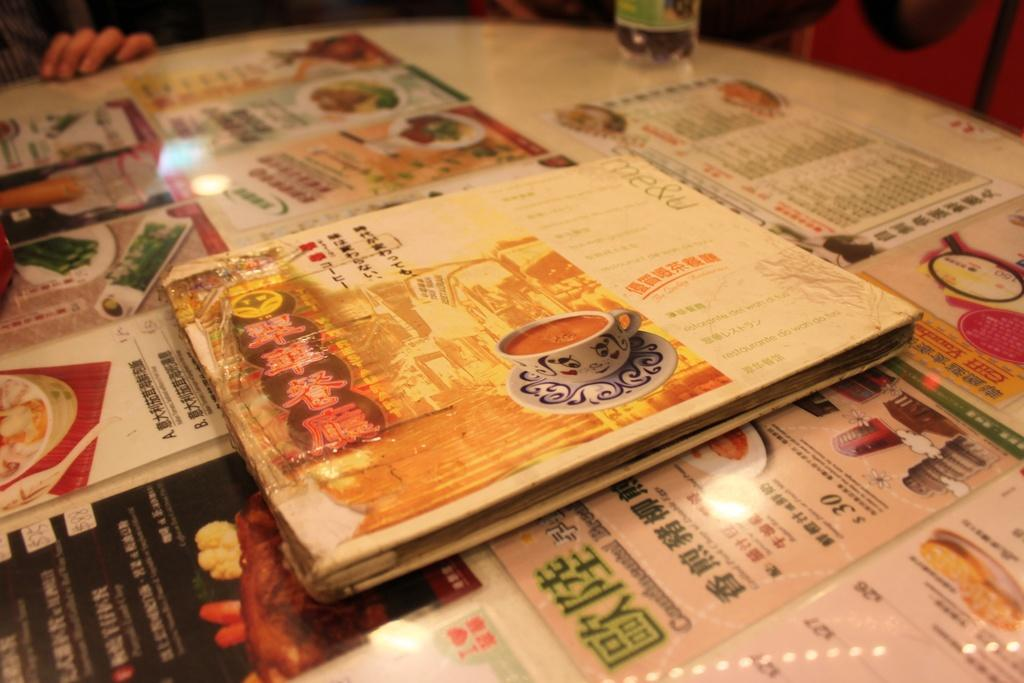Provide a one-sentence caption for the provided image. Several Chinese menus sit on a table with one dish costing $30. 